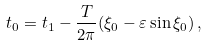Convert formula to latex. <formula><loc_0><loc_0><loc_500><loc_500>t _ { 0 } = t _ { 1 } - \frac { T } { 2 \pi } ( \xi _ { 0 } - \varepsilon \sin \xi _ { 0 } ) \, ,</formula> 